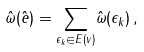<formula> <loc_0><loc_0><loc_500><loc_500>\hat { \omega } ( \hat { e } ) = \underset { \epsilon _ { k } \in E ( v ) } { \sum } \hat { \omega } ( \epsilon _ { k } ) \, ,</formula> 